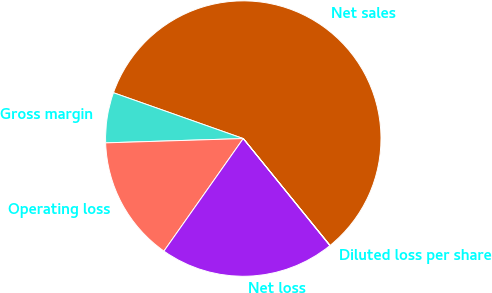<chart> <loc_0><loc_0><loc_500><loc_500><pie_chart><fcel>Net sales<fcel>Gross margin<fcel>Operating loss<fcel>Net loss<fcel>Diluted loss per share<nl><fcel>58.74%<fcel>5.9%<fcel>14.73%<fcel>20.6%<fcel>0.03%<nl></chart> 